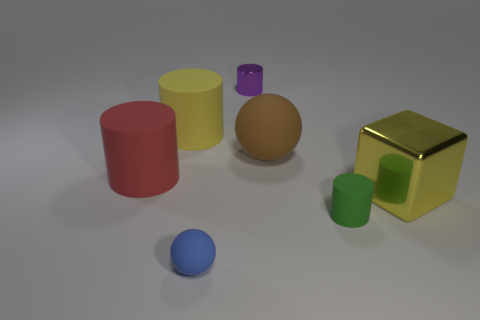Add 1 small green objects. How many objects exist? 8 Subtract all cylinders. How many objects are left? 3 Add 1 metallic cylinders. How many metallic cylinders exist? 2 Subtract 0 red blocks. How many objects are left? 7 Subtract all shiny cylinders. Subtract all small matte spheres. How many objects are left? 5 Add 1 big brown balls. How many big brown balls are left? 2 